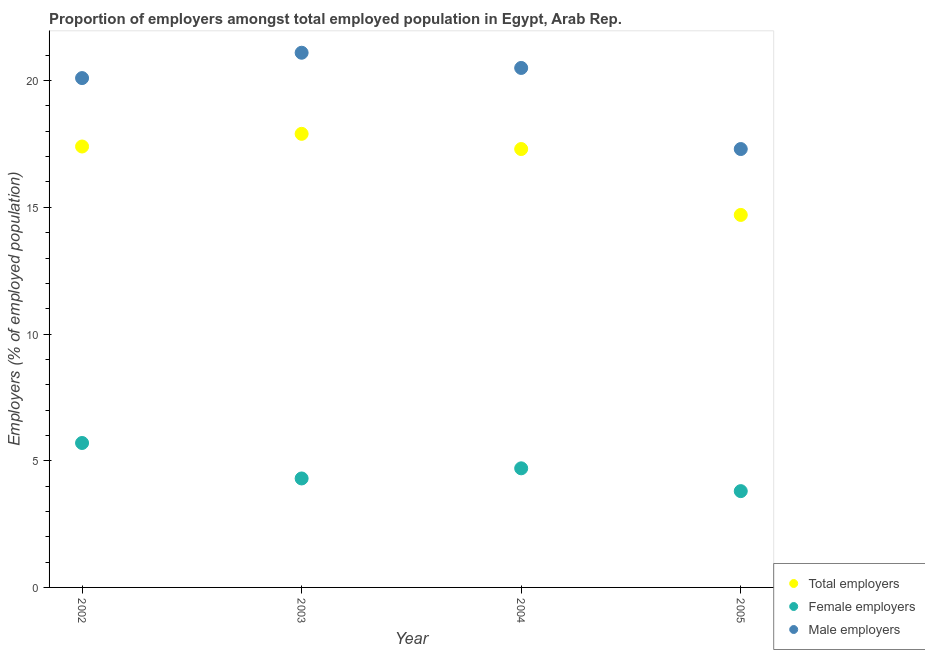How many different coloured dotlines are there?
Your answer should be compact. 3. Is the number of dotlines equal to the number of legend labels?
Give a very brief answer. Yes. What is the percentage of total employers in 2003?
Provide a succinct answer. 17.9. Across all years, what is the maximum percentage of total employers?
Provide a short and direct response. 17.9. Across all years, what is the minimum percentage of total employers?
Give a very brief answer. 14.7. In which year was the percentage of female employers maximum?
Offer a terse response. 2002. In which year was the percentage of total employers minimum?
Offer a terse response. 2005. What is the total percentage of male employers in the graph?
Your response must be concise. 79. What is the difference between the percentage of male employers in 2002 and that in 2005?
Your answer should be compact. 2.8. What is the difference between the percentage of male employers in 2002 and the percentage of female employers in 2005?
Your answer should be compact. 16.3. What is the average percentage of female employers per year?
Provide a succinct answer. 4.62. In the year 2003, what is the difference between the percentage of total employers and percentage of male employers?
Provide a succinct answer. -3.2. What is the ratio of the percentage of total employers in 2002 to that in 2005?
Offer a terse response. 1.18. Is the difference between the percentage of male employers in 2002 and 2005 greater than the difference between the percentage of total employers in 2002 and 2005?
Make the answer very short. Yes. What is the difference between the highest and the second highest percentage of total employers?
Make the answer very short. 0.5. What is the difference between the highest and the lowest percentage of total employers?
Your response must be concise. 3.2. Is the sum of the percentage of total employers in 2002 and 2005 greater than the maximum percentage of female employers across all years?
Ensure brevity in your answer.  Yes. Does the percentage of male employers monotonically increase over the years?
Your answer should be very brief. No. How many years are there in the graph?
Keep it short and to the point. 4. What is the difference between two consecutive major ticks on the Y-axis?
Offer a very short reply. 5. Does the graph contain grids?
Offer a terse response. No. How many legend labels are there?
Your response must be concise. 3. How are the legend labels stacked?
Ensure brevity in your answer.  Vertical. What is the title of the graph?
Provide a short and direct response. Proportion of employers amongst total employed population in Egypt, Arab Rep. What is the label or title of the X-axis?
Give a very brief answer. Year. What is the label or title of the Y-axis?
Offer a terse response. Employers (% of employed population). What is the Employers (% of employed population) of Total employers in 2002?
Ensure brevity in your answer.  17.4. What is the Employers (% of employed population) in Female employers in 2002?
Offer a very short reply. 5.7. What is the Employers (% of employed population) of Male employers in 2002?
Provide a succinct answer. 20.1. What is the Employers (% of employed population) of Total employers in 2003?
Give a very brief answer. 17.9. What is the Employers (% of employed population) of Female employers in 2003?
Make the answer very short. 4.3. What is the Employers (% of employed population) in Male employers in 2003?
Your response must be concise. 21.1. What is the Employers (% of employed population) in Total employers in 2004?
Offer a terse response. 17.3. What is the Employers (% of employed population) in Female employers in 2004?
Make the answer very short. 4.7. What is the Employers (% of employed population) of Total employers in 2005?
Provide a short and direct response. 14.7. What is the Employers (% of employed population) of Female employers in 2005?
Keep it short and to the point. 3.8. What is the Employers (% of employed population) in Male employers in 2005?
Give a very brief answer. 17.3. Across all years, what is the maximum Employers (% of employed population) of Total employers?
Keep it short and to the point. 17.9. Across all years, what is the maximum Employers (% of employed population) of Female employers?
Your answer should be compact. 5.7. Across all years, what is the maximum Employers (% of employed population) in Male employers?
Keep it short and to the point. 21.1. Across all years, what is the minimum Employers (% of employed population) of Total employers?
Give a very brief answer. 14.7. Across all years, what is the minimum Employers (% of employed population) of Female employers?
Ensure brevity in your answer.  3.8. Across all years, what is the minimum Employers (% of employed population) of Male employers?
Provide a succinct answer. 17.3. What is the total Employers (% of employed population) of Total employers in the graph?
Provide a short and direct response. 67.3. What is the total Employers (% of employed population) of Female employers in the graph?
Your response must be concise. 18.5. What is the total Employers (% of employed population) of Male employers in the graph?
Offer a very short reply. 79. What is the difference between the Employers (% of employed population) in Total employers in 2002 and that in 2003?
Make the answer very short. -0.5. What is the difference between the Employers (% of employed population) in Total employers in 2002 and that in 2005?
Give a very brief answer. 2.7. What is the difference between the Employers (% of employed population) in Female employers in 2002 and that in 2005?
Ensure brevity in your answer.  1.9. What is the difference between the Employers (% of employed population) of Male employers in 2002 and that in 2005?
Your response must be concise. 2.8. What is the difference between the Employers (% of employed population) in Male employers in 2003 and that in 2004?
Your answer should be compact. 0.6. What is the difference between the Employers (% of employed population) of Female employers in 2003 and that in 2005?
Your response must be concise. 0.5. What is the difference between the Employers (% of employed population) of Male employers in 2003 and that in 2005?
Ensure brevity in your answer.  3.8. What is the difference between the Employers (% of employed population) of Female employers in 2004 and that in 2005?
Give a very brief answer. 0.9. What is the difference between the Employers (% of employed population) in Total employers in 2002 and the Employers (% of employed population) in Female employers in 2003?
Make the answer very short. 13.1. What is the difference between the Employers (% of employed population) of Female employers in 2002 and the Employers (% of employed population) of Male employers in 2003?
Your answer should be very brief. -15.4. What is the difference between the Employers (% of employed population) of Total employers in 2002 and the Employers (% of employed population) of Male employers in 2004?
Provide a succinct answer. -3.1. What is the difference between the Employers (% of employed population) in Female employers in 2002 and the Employers (% of employed population) in Male employers in 2004?
Give a very brief answer. -14.8. What is the difference between the Employers (% of employed population) in Female employers in 2002 and the Employers (% of employed population) in Male employers in 2005?
Offer a very short reply. -11.6. What is the difference between the Employers (% of employed population) in Total employers in 2003 and the Employers (% of employed population) in Male employers in 2004?
Make the answer very short. -2.6. What is the difference between the Employers (% of employed population) of Female employers in 2003 and the Employers (% of employed population) of Male employers in 2004?
Your answer should be very brief. -16.2. What is the difference between the Employers (% of employed population) in Total employers in 2004 and the Employers (% of employed population) in Female employers in 2005?
Offer a terse response. 13.5. What is the difference between the Employers (% of employed population) of Total employers in 2004 and the Employers (% of employed population) of Male employers in 2005?
Offer a very short reply. 0. What is the difference between the Employers (% of employed population) in Female employers in 2004 and the Employers (% of employed population) in Male employers in 2005?
Keep it short and to the point. -12.6. What is the average Employers (% of employed population) of Total employers per year?
Ensure brevity in your answer.  16.82. What is the average Employers (% of employed population) of Female employers per year?
Your response must be concise. 4.62. What is the average Employers (% of employed population) of Male employers per year?
Provide a succinct answer. 19.75. In the year 2002, what is the difference between the Employers (% of employed population) of Total employers and Employers (% of employed population) of Female employers?
Your response must be concise. 11.7. In the year 2002, what is the difference between the Employers (% of employed population) of Total employers and Employers (% of employed population) of Male employers?
Provide a short and direct response. -2.7. In the year 2002, what is the difference between the Employers (% of employed population) in Female employers and Employers (% of employed population) in Male employers?
Your answer should be very brief. -14.4. In the year 2003, what is the difference between the Employers (% of employed population) in Total employers and Employers (% of employed population) in Female employers?
Offer a very short reply. 13.6. In the year 2003, what is the difference between the Employers (% of employed population) of Female employers and Employers (% of employed population) of Male employers?
Provide a short and direct response. -16.8. In the year 2004, what is the difference between the Employers (% of employed population) in Total employers and Employers (% of employed population) in Female employers?
Offer a very short reply. 12.6. In the year 2004, what is the difference between the Employers (% of employed population) of Female employers and Employers (% of employed population) of Male employers?
Your answer should be very brief. -15.8. In the year 2005, what is the difference between the Employers (% of employed population) in Total employers and Employers (% of employed population) in Male employers?
Provide a succinct answer. -2.6. In the year 2005, what is the difference between the Employers (% of employed population) in Female employers and Employers (% of employed population) in Male employers?
Ensure brevity in your answer.  -13.5. What is the ratio of the Employers (% of employed population) in Total employers in 2002 to that in 2003?
Keep it short and to the point. 0.97. What is the ratio of the Employers (% of employed population) in Female employers in 2002 to that in 2003?
Offer a terse response. 1.33. What is the ratio of the Employers (% of employed population) in Male employers in 2002 to that in 2003?
Make the answer very short. 0.95. What is the ratio of the Employers (% of employed population) of Female employers in 2002 to that in 2004?
Your answer should be compact. 1.21. What is the ratio of the Employers (% of employed population) of Male employers in 2002 to that in 2004?
Keep it short and to the point. 0.98. What is the ratio of the Employers (% of employed population) in Total employers in 2002 to that in 2005?
Offer a terse response. 1.18. What is the ratio of the Employers (% of employed population) in Female employers in 2002 to that in 2005?
Ensure brevity in your answer.  1.5. What is the ratio of the Employers (% of employed population) of Male employers in 2002 to that in 2005?
Your answer should be compact. 1.16. What is the ratio of the Employers (% of employed population) in Total employers in 2003 to that in 2004?
Give a very brief answer. 1.03. What is the ratio of the Employers (% of employed population) in Female employers in 2003 to that in 2004?
Provide a short and direct response. 0.91. What is the ratio of the Employers (% of employed population) in Male employers in 2003 to that in 2004?
Your response must be concise. 1.03. What is the ratio of the Employers (% of employed population) in Total employers in 2003 to that in 2005?
Ensure brevity in your answer.  1.22. What is the ratio of the Employers (% of employed population) of Female employers in 2003 to that in 2005?
Provide a short and direct response. 1.13. What is the ratio of the Employers (% of employed population) in Male employers in 2003 to that in 2005?
Your response must be concise. 1.22. What is the ratio of the Employers (% of employed population) of Total employers in 2004 to that in 2005?
Your answer should be compact. 1.18. What is the ratio of the Employers (% of employed population) in Female employers in 2004 to that in 2005?
Your answer should be compact. 1.24. What is the ratio of the Employers (% of employed population) in Male employers in 2004 to that in 2005?
Provide a succinct answer. 1.19. What is the difference between the highest and the second highest Employers (% of employed population) of Total employers?
Your answer should be compact. 0.5. What is the difference between the highest and the second highest Employers (% of employed population) in Female employers?
Offer a very short reply. 1. What is the difference between the highest and the lowest Employers (% of employed population) in Total employers?
Make the answer very short. 3.2. What is the difference between the highest and the lowest Employers (% of employed population) in Male employers?
Your answer should be compact. 3.8. 